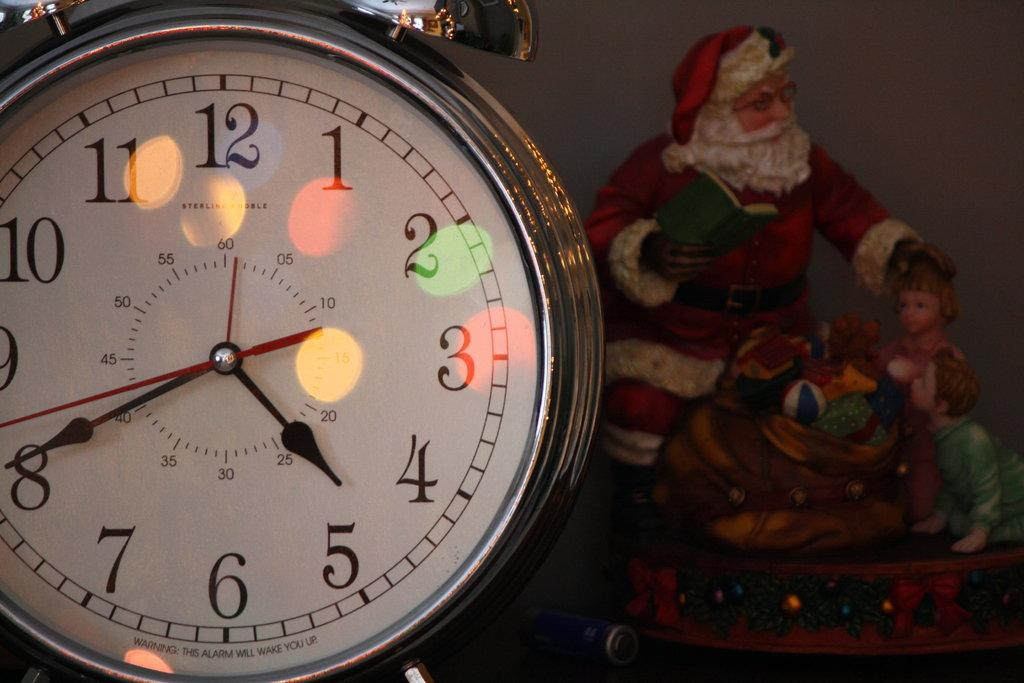<image>
Render a clear and concise summary of the photo. A figurine of Santa Claus reading to children sits in the background, while a Sterling and Noble alarm clock is in the foreground with a time shown of 4:40. 